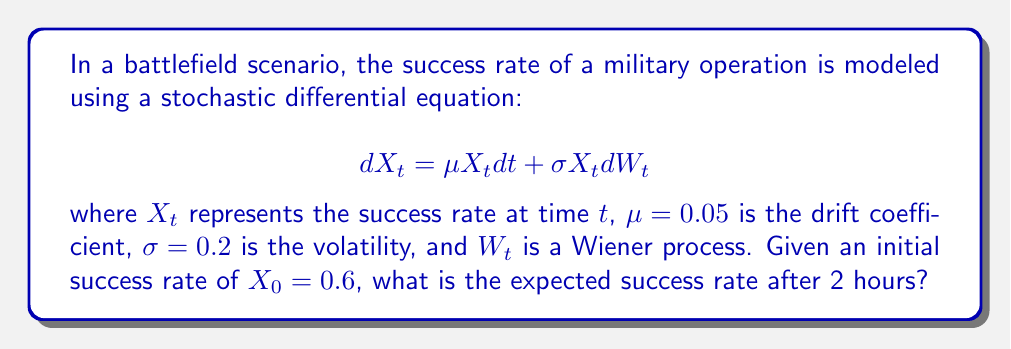Solve this math problem. To solve this problem, we'll use the properties of geometric Brownian motion, which is described by the given stochastic differential equation.

1) For a geometric Brownian motion, the expected value at time $t$ is given by:

   $$E[X_t] = X_0 e^{\mu t}$$

2) We're given:
   - Initial success rate $X_0 = 0.6$
   - Drift coefficient $\mu = 0.05$
   - Time $t = 2$ hours

3) Substituting these values into the formula:

   $$E[X_2] = 0.6 e^{0.05 * 2}$$

4) Calculate the exponent:
   $$0.05 * 2 = 0.1$$

5) Now we have:
   $$E[X_2] = 0.6 e^{0.1}$$

6) Calculate $e^{0.1}$:
   $$e^{0.1} \approx 1.1052$$

7) Finally, multiply:
   $$E[X_2] = 0.6 * 1.1052 \approx 0.6631$$

Thus, the expected success rate after 2 hours is approximately 0.6631 or 66.31%.
Answer: 0.6631 